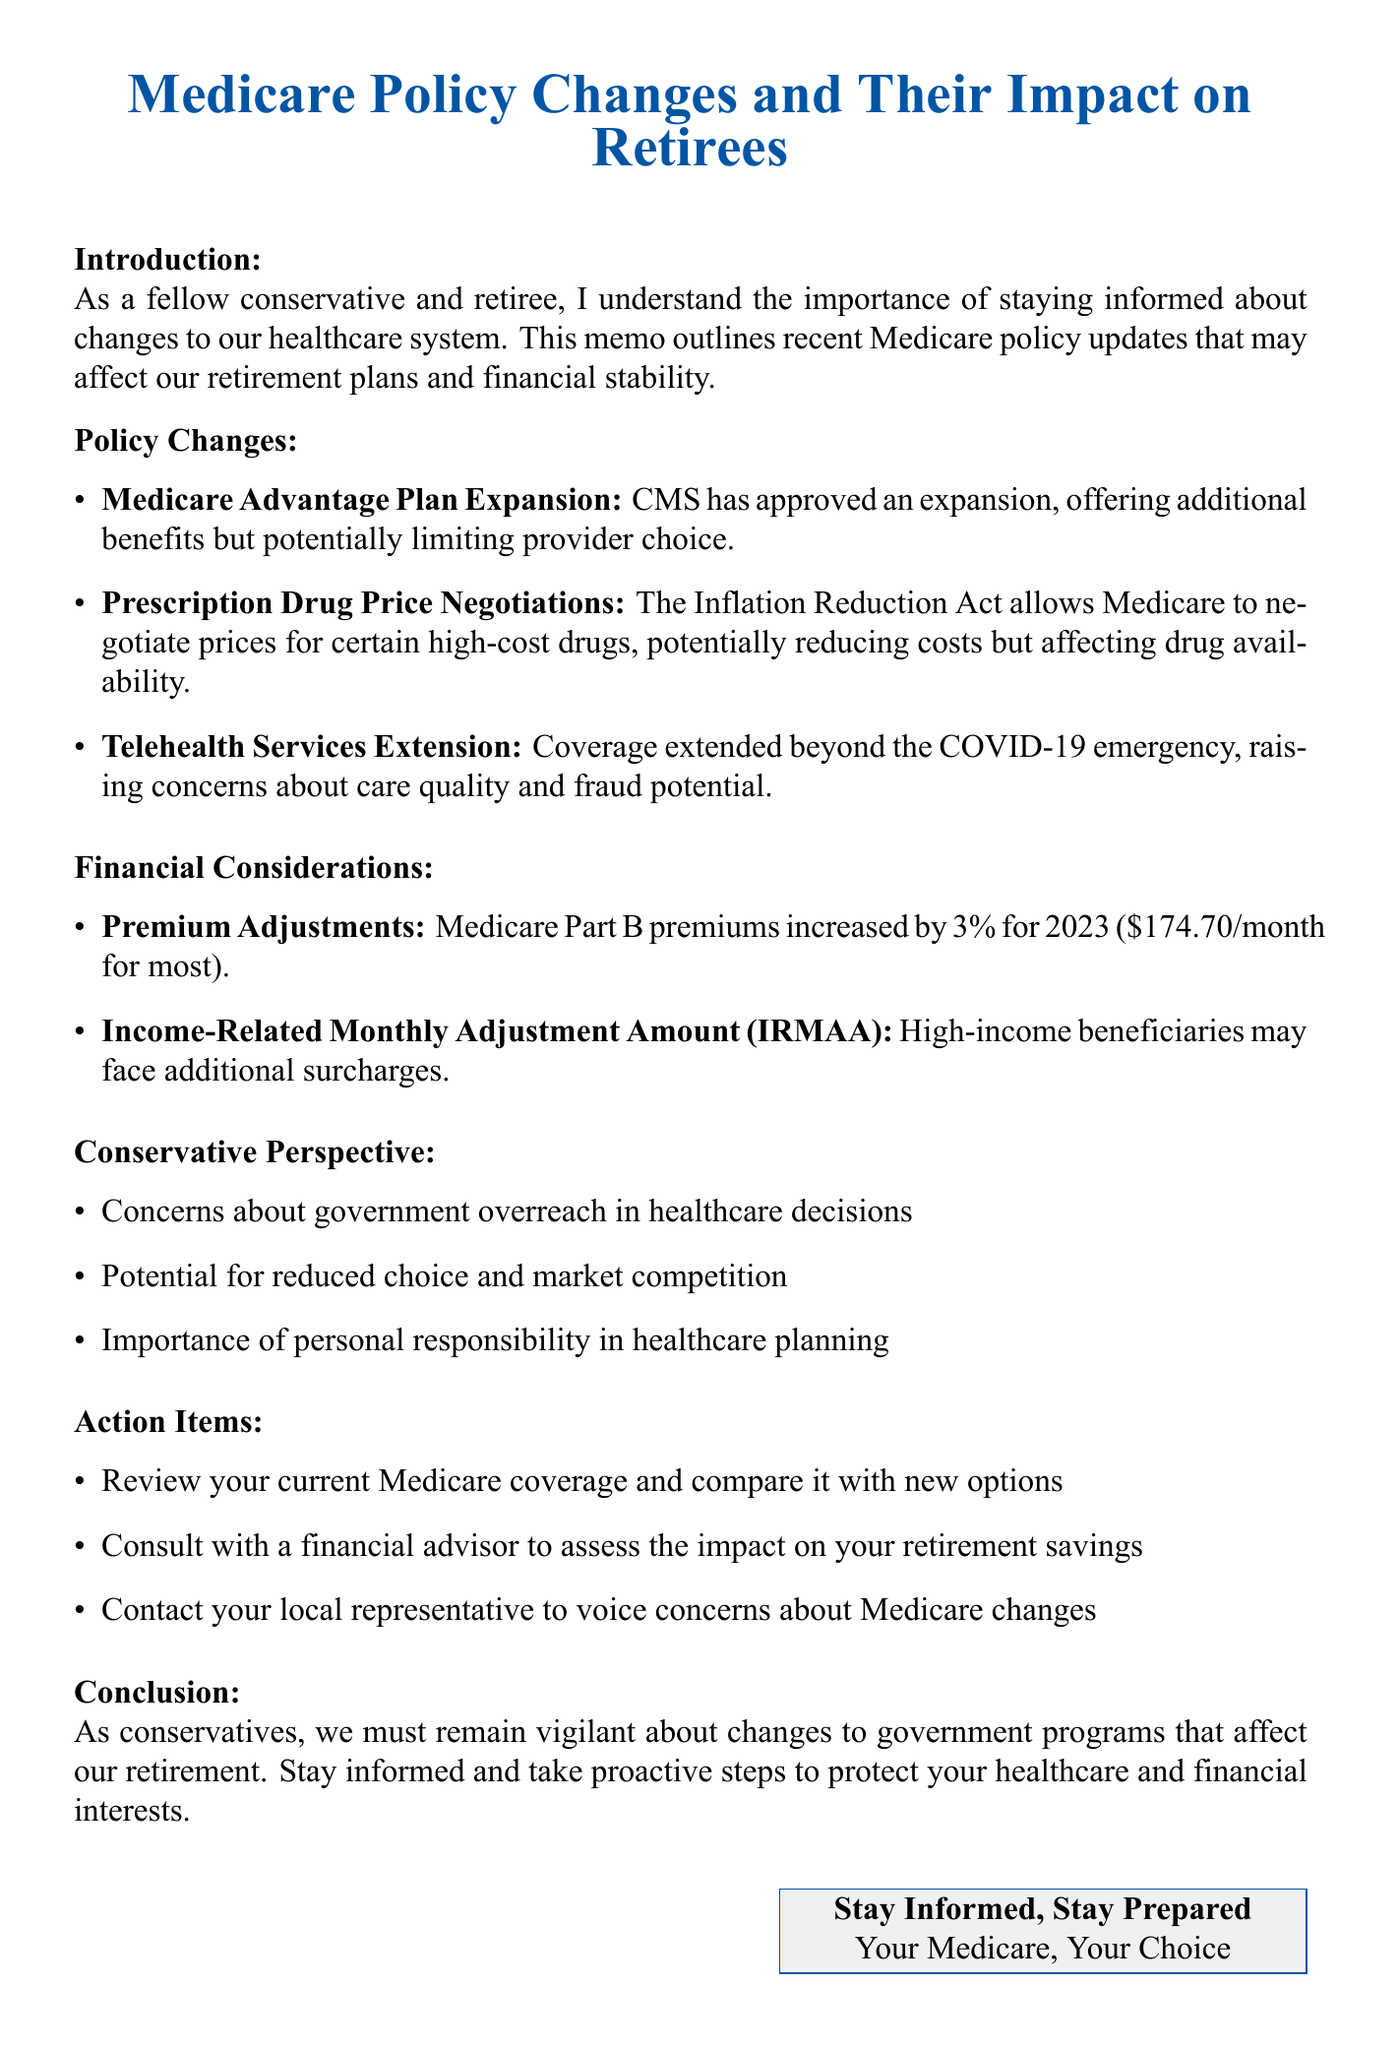What is the title of the memo? The title of the memo is provided at the beginning and summarizes the content, which is about Medicare policy changes.
Answer: Medicare Policy Changes and Their Impact on Retirees What is the increase percentage of Medicare Part B premiums for 2023? The document specifies the percentage increase of Medicare Part B premiums for 2023.
Answer: 3% What government act allows Medicare to negotiate drug prices? The document refers to a specific act that enables price negotiation for high-cost drugs.
Answer: Inflation Reduction Act of 2022 What concern is raised about telehealth services? The document highlights a specific concern regarding the quality of care provided through telehealth services.
Answer: Quality of care What should retirees review according to the action items? The action items suggest a specific task for retirees to assess their healthcare options.
Answer: Current Medicare coverage Why might high-income beneficiaries see higher costs? The document explains a particular factor that could lead to surcharges for specific beneficiaries.
Answer: Additional surcharges on premiums What is a major conservative concern mentioned in the memo? The document lists general concerns from a conservative perspective regarding healthcare changes.
Answer: Government overreach What should retirees do to voice their concerns about Medicare changes? The action items include a specific recommendation for retirees to express their opinions.
Answer: Contact your local representative 